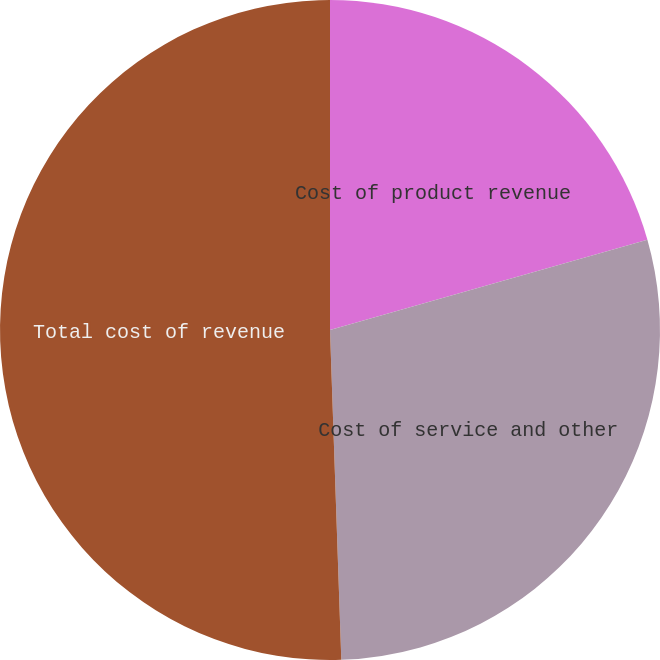Convert chart to OTSL. <chart><loc_0><loc_0><loc_500><loc_500><pie_chart><fcel>Cost of product revenue<fcel>Cost of service and other<fcel>Total cost of revenue<nl><fcel>20.59%<fcel>28.87%<fcel>50.55%<nl></chart> 